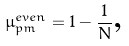Convert formula to latex. <formula><loc_0><loc_0><loc_500><loc_500>\mu ^ { e v e n } _ { p m } = 1 - \frac { 1 } { N } \text {,}</formula> 